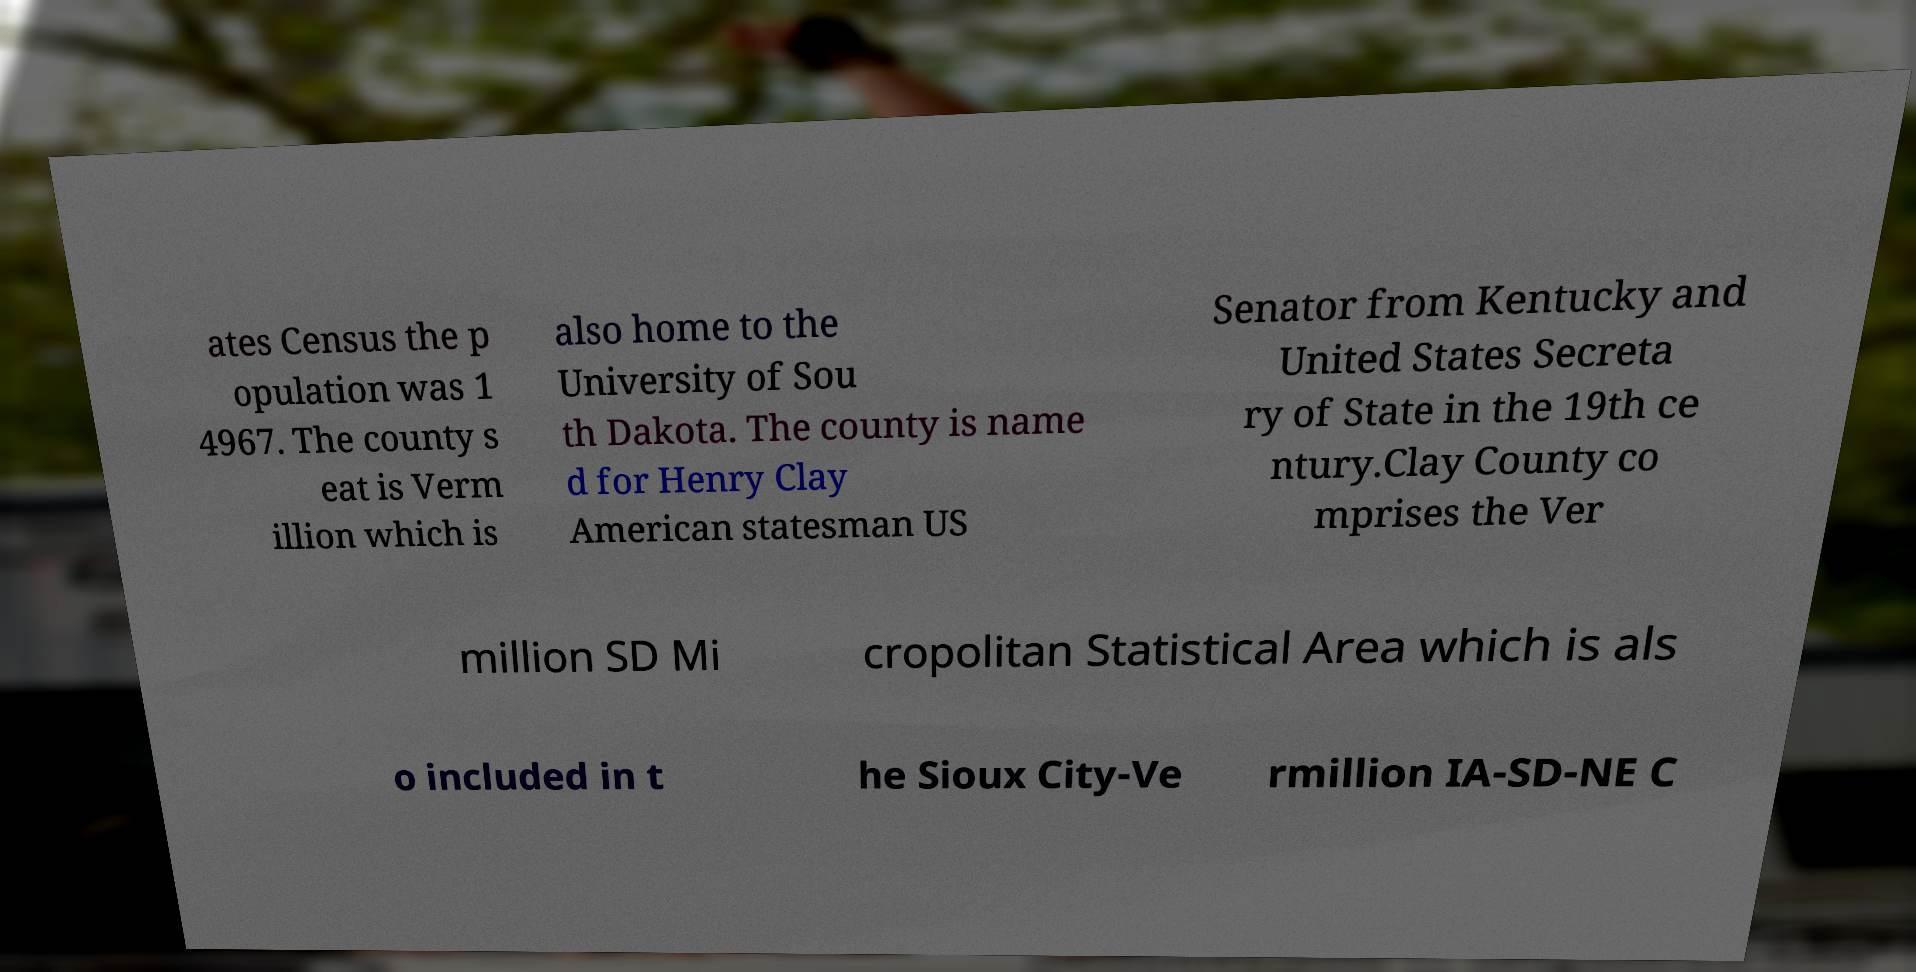What messages or text are displayed in this image? I need them in a readable, typed format. ates Census the p opulation was 1 4967. The county s eat is Verm illion which is also home to the University of Sou th Dakota. The county is name d for Henry Clay American statesman US Senator from Kentucky and United States Secreta ry of State in the 19th ce ntury.Clay County co mprises the Ver million SD Mi cropolitan Statistical Area which is als o included in t he Sioux City-Ve rmillion IA-SD-NE C 